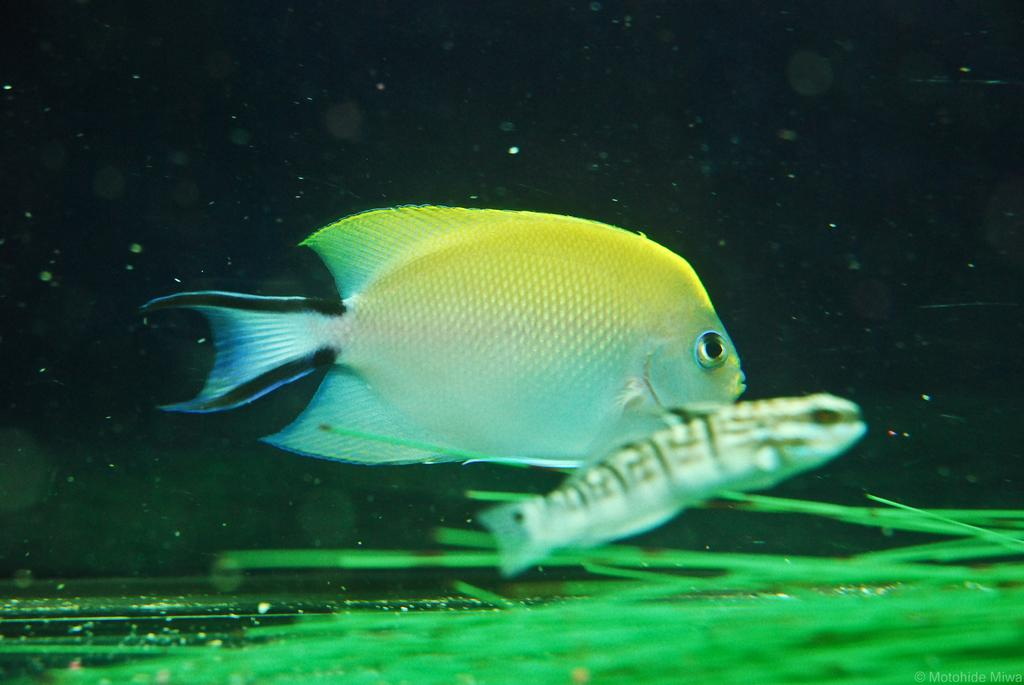What type of animals can be seen in the image? There are fishes in the image. What other elements are present in the image besides the fishes? There is greenery in the image. What type of gate can be seen in the image? There is no gate present in the image; it features fishes and greenery. How many lines are visible in the image? There is no specific mention of lines in the image, as it primarily features fishes and greenery. 